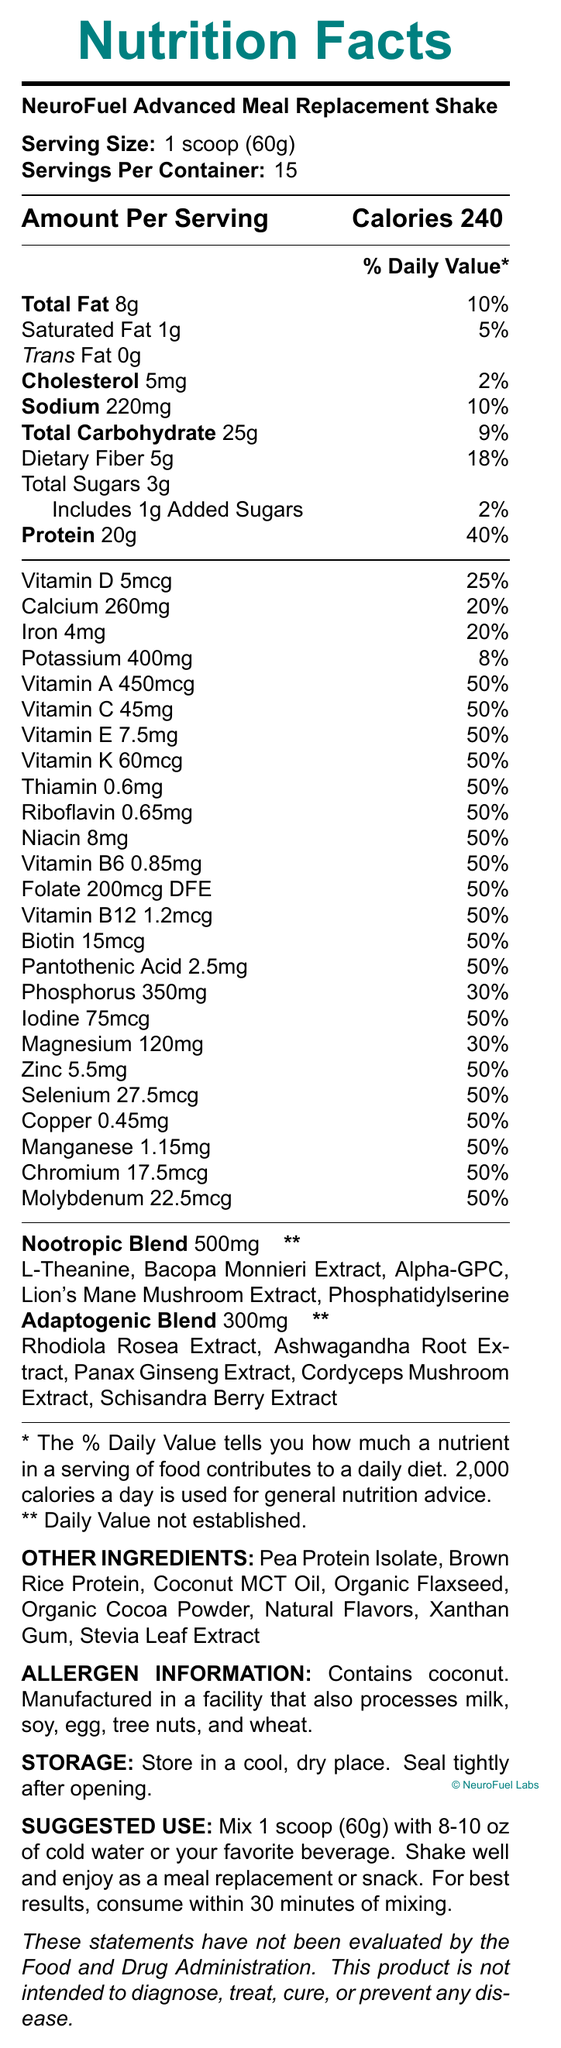what is the serving size for NeuroFuel Advanced Meal Replacement Shake? The serving size is clearly stated at the beginning of the document as 1 scoop (60g).
Answer: 1 scoop (60g) how many servings per container does the product have? The document lists the servings per container as 15.
Answer: 15 how much protein is in one serving? The protein content per serving is listed as 20g.
Answer: 20g what is the total amount of vitamins and minerals with 50% daily value per serving? There are 17 vitamins and minerals listed with a daily value of 50% each.
Answer: 17 what is the first ingredient listed in the nootropic blend? The nootropic blend ingredients are listed in a specific order, with L-Theanine being the first.
Answer: L-Theanine how much cholesterol does one serving of the product contain? The cholesterol content per serving is listed as 5mg.
Answer: 5mg which ingredient does the adaptogenic blend end with? A. Cordyceps Mushroom Extract B. Schisandra Berry Extract C. Rhodiola Rosea Extract D. Ashwagandha Root Extract The adaptogenic blend ends with Schisandra Berry Extract according to the document.
Answer: B does the product contain any added sugars? The document states that it includes 1g of added sugars.
Answer: Yes how many calories are in one serving? The document lists the calorie content of one serving as 240.
Answer: 240 which nutrient has the lowest daily value percentage per serving? A. Vitamin B12 B. Sodium C. Added Sugars D. Cholesterol Cholesterol has a daily value percentage of 2%, which is lower than the other options.
Answer: D is the product effective for diagnosis, treatment, cure, or prevention of any disease? The document explicitly states that the product is not intended to diagnose, treat, cure, or prevent any disease.
Answer: No summarize the key information provided by the document. The explanation includes a comprehensive summary of the main points in the document, covering the essential details about the product's nutritional content, unique ingredient blends, and usage instructions.
Answer: The document outlines the nutritional facts of NeuroFuel Advanced Meal Replacement Shake, highlighting its nutritional content, ingredient blends, allergens, and additional information. Each serving size is 1 scoop (60g) and contains 240 calories. The product includes a nootropic blend of 500mg and an adaptogenic blend of 300mg, designed to enhance cognitive function and stress resilience. It also provides details on how to use and store the product. how much phosphorus is in one serving? The document mentions that the phosphorus content per serving is 350mg.
Answer: 350mg what are the main purposes of the NeuroFuel Advanced Meal Replacement Shake as suggested by the research notes? The research notes in the document specify that the formula is designed to support cognitive function, enhance focus, and improve stress resilience.
Answer: To support cognitive function, enhance focus, and improve stress resilience. how many different types of vitamins and minerals are listed in the document? The document lists 27 different types of vitamins and minerals along with their amounts and daily values.
Answer: 27 what is the amount of dietary fiber in one serving? The dietary fiber content per serving is listed as 5g.
Answer: 5g what allergens are listed in the allergen information? The allergen information provided in the document states that the product contains coconut and is manufactured in a facility that processes milk, soy, egg, tree nuts, and wheat.
Answer: Coconut. Manufactured in a facility that also processes milk, soy, egg, tree nuts, and wheat. is there a potassium content in the shake, and if so, how much? The document lists potassium content per serving as 400mg.
Answer: Yes, 400mg how should the product be stored to maintain its quality? The storage instructions specify storing the product in a cool, dry place and sealing it tightly after opening.
Answer: In a cool, dry place, sealed tightly after opening. what is the primary ingredient in the Other Ingredients section? A. Pea Protein Isolate B. Brown Rice Protein C. Coconut MCT Oil D. Organic Flaxseed The primary ingredient listed in the Other Ingredients section is Pea Protein Isolate.
Answer: A what specific benefit is not explicitly stated in the document's research notes? The document's research notes do not explicitly quantify the long-term benefits of regular consumption, stating that further studies are needed.
Answer: I don't know 